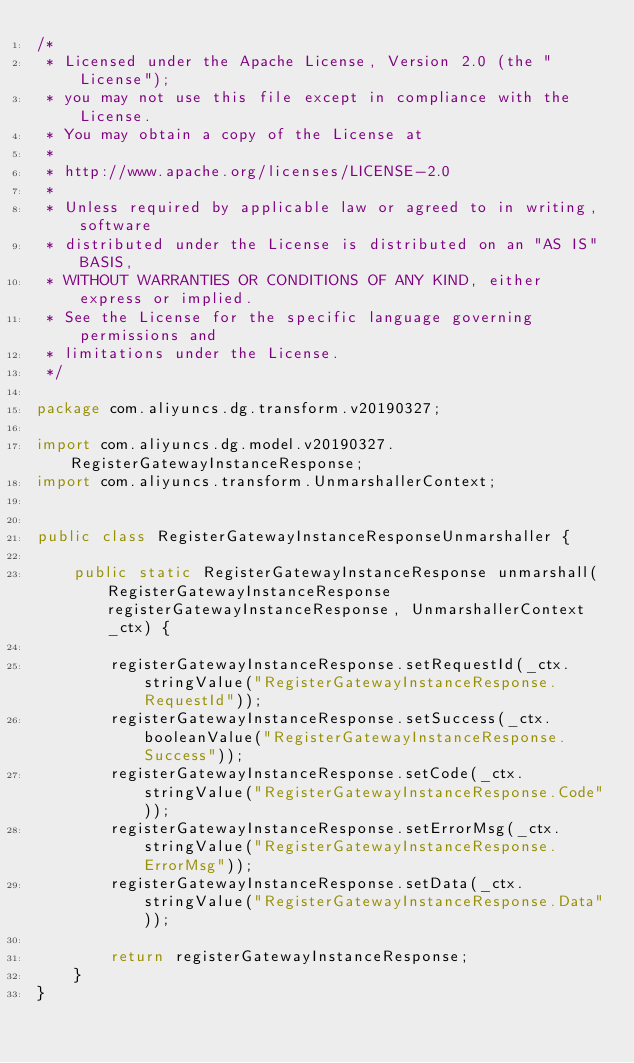Convert code to text. <code><loc_0><loc_0><loc_500><loc_500><_Java_>/*
 * Licensed under the Apache License, Version 2.0 (the "License");
 * you may not use this file except in compliance with the License.
 * You may obtain a copy of the License at
 *
 * http://www.apache.org/licenses/LICENSE-2.0
 *
 * Unless required by applicable law or agreed to in writing, software
 * distributed under the License is distributed on an "AS IS" BASIS,
 * WITHOUT WARRANTIES OR CONDITIONS OF ANY KIND, either express or implied.
 * See the License for the specific language governing permissions and
 * limitations under the License.
 */

package com.aliyuncs.dg.transform.v20190327;

import com.aliyuncs.dg.model.v20190327.RegisterGatewayInstanceResponse;
import com.aliyuncs.transform.UnmarshallerContext;


public class RegisterGatewayInstanceResponseUnmarshaller {

	public static RegisterGatewayInstanceResponse unmarshall(RegisterGatewayInstanceResponse registerGatewayInstanceResponse, UnmarshallerContext _ctx) {
		
		registerGatewayInstanceResponse.setRequestId(_ctx.stringValue("RegisterGatewayInstanceResponse.RequestId"));
		registerGatewayInstanceResponse.setSuccess(_ctx.booleanValue("RegisterGatewayInstanceResponse.Success"));
		registerGatewayInstanceResponse.setCode(_ctx.stringValue("RegisterGatewayInstanceResponse.Code"));
		registerGatewayInstanceResponse.setErrorMsg(_ctx.stringValue("RegisterGatewayInstanceResponse.ErrorMsg"));
		registerGatewayInstanceResponse.setData(_ctx.stringValue("RegisterGatewayInstanceResponse.Data"));
	 
	 	return registerGatewayInstanceResponse;
	}
}</code> 